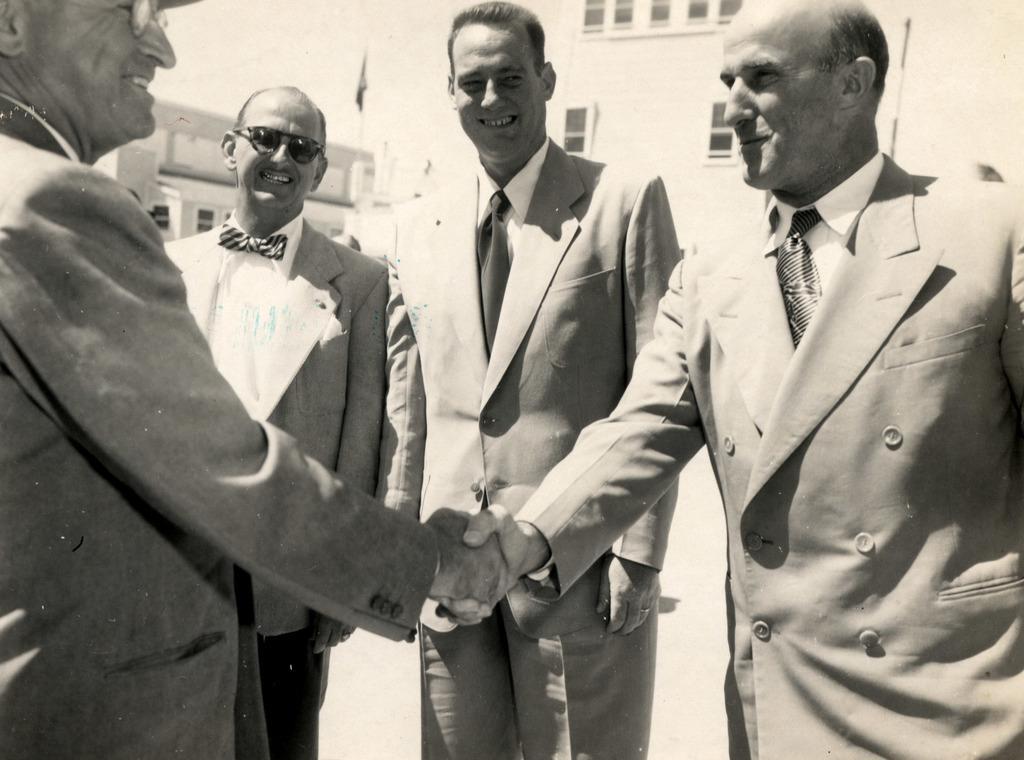Can you describe this image briefly? It is a black and white image there are four men, among them the first person and the last person are greeting each other and all of them were smiling and in the background there is a building. 